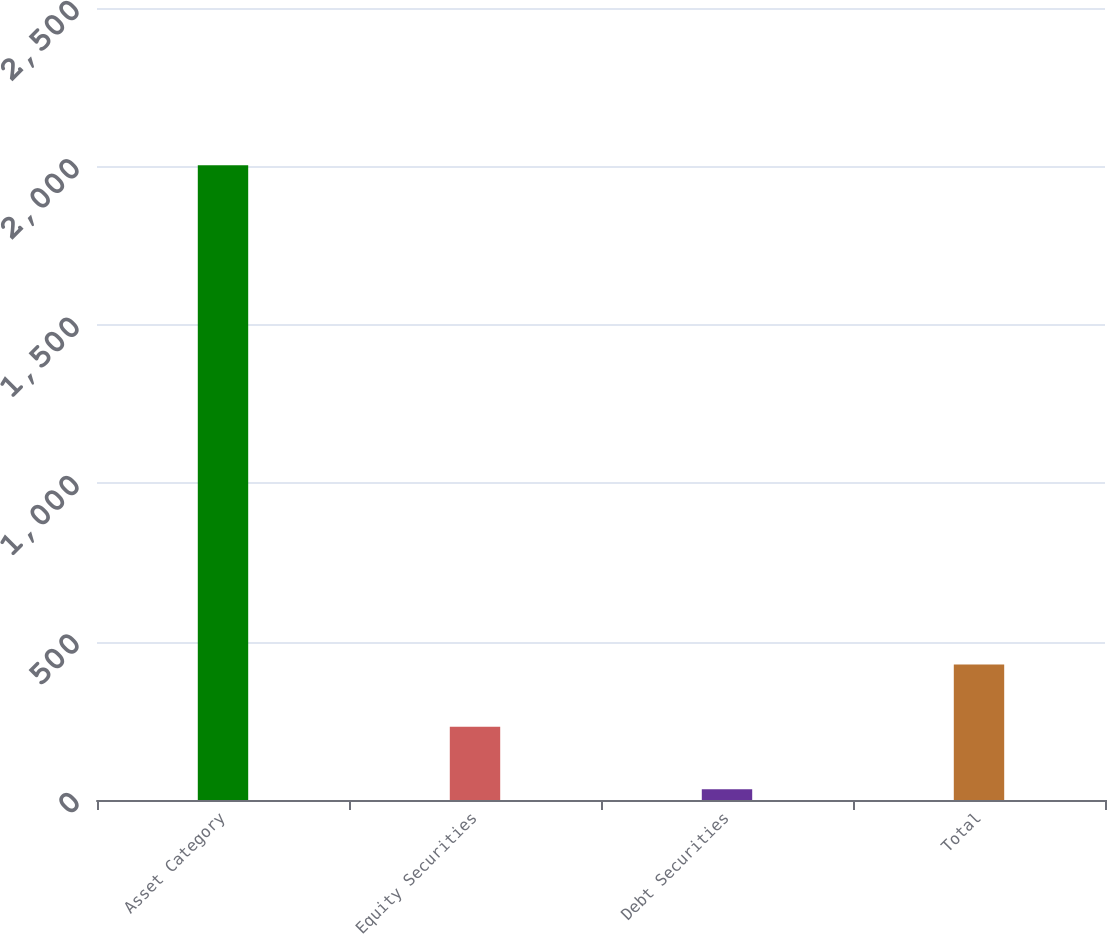Convert chart. <chart><loc_0><loc_0><loc_500><loc_500><bar_chart><fcel>Asset Category<fcel>Equity Securities<fcel>Debt Securities<fcel>Total<nl><fcel>2004<fcel>231<fcel>34<fcel>428<nl></chart> 